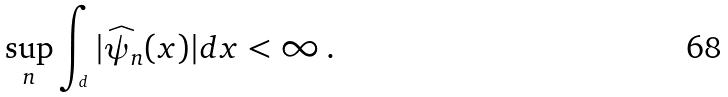Convert formula to latex. <formula><loc_0><loc_0><loc_500><loc_500>\sup _ { n } \int _ { \real ^ { d } } | \widehat { \psi } _ { n } ( x ) | d x < \infty \, .</formula> 